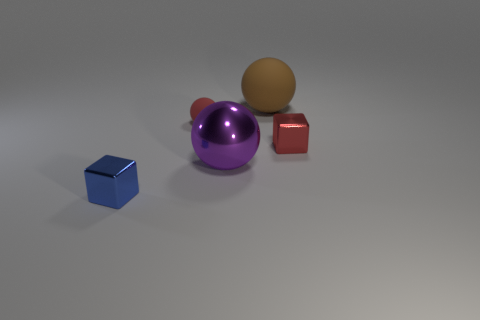What material is the cube that is the same color as the small ball?
Ensure brevity in your answer.  Metal. What number of other things are there of the same color as the small ball?
Ensure brevity in your answer.  1. What number of brown things are the same shape as the purple object?
Keep it short and to the point. 1. There is a brown ball that is the same material as the small red ball; what is its size?
Give a very brief answer. Large. There is a tiny thing that is in front of the small red matte ball and left of the red metal thing; what is its material?
Provide a short and direct response. Metal. What number of matte objects are the same size as the brown rubber ball?
Your answer should be very brief. 0. There is a tiny red object that is the same shape as the big purple object; what is it made of?
Your response must be concise. Rubber. What number of things are shiny blocks that are right of the large brown thing or brown things that are right of the small rubber sphere?
Offer a terse response. 2. Is the shape of the tiny matte thing the same as the tiny object that is on the right side of the purple sphere?
Keep it short and to the point. No. What is the shape of the large thing that is behind the metallic block that is to the right of the tiny block that is left of the large purple shiny thing?
Keep it short and to the point. Sphere. 